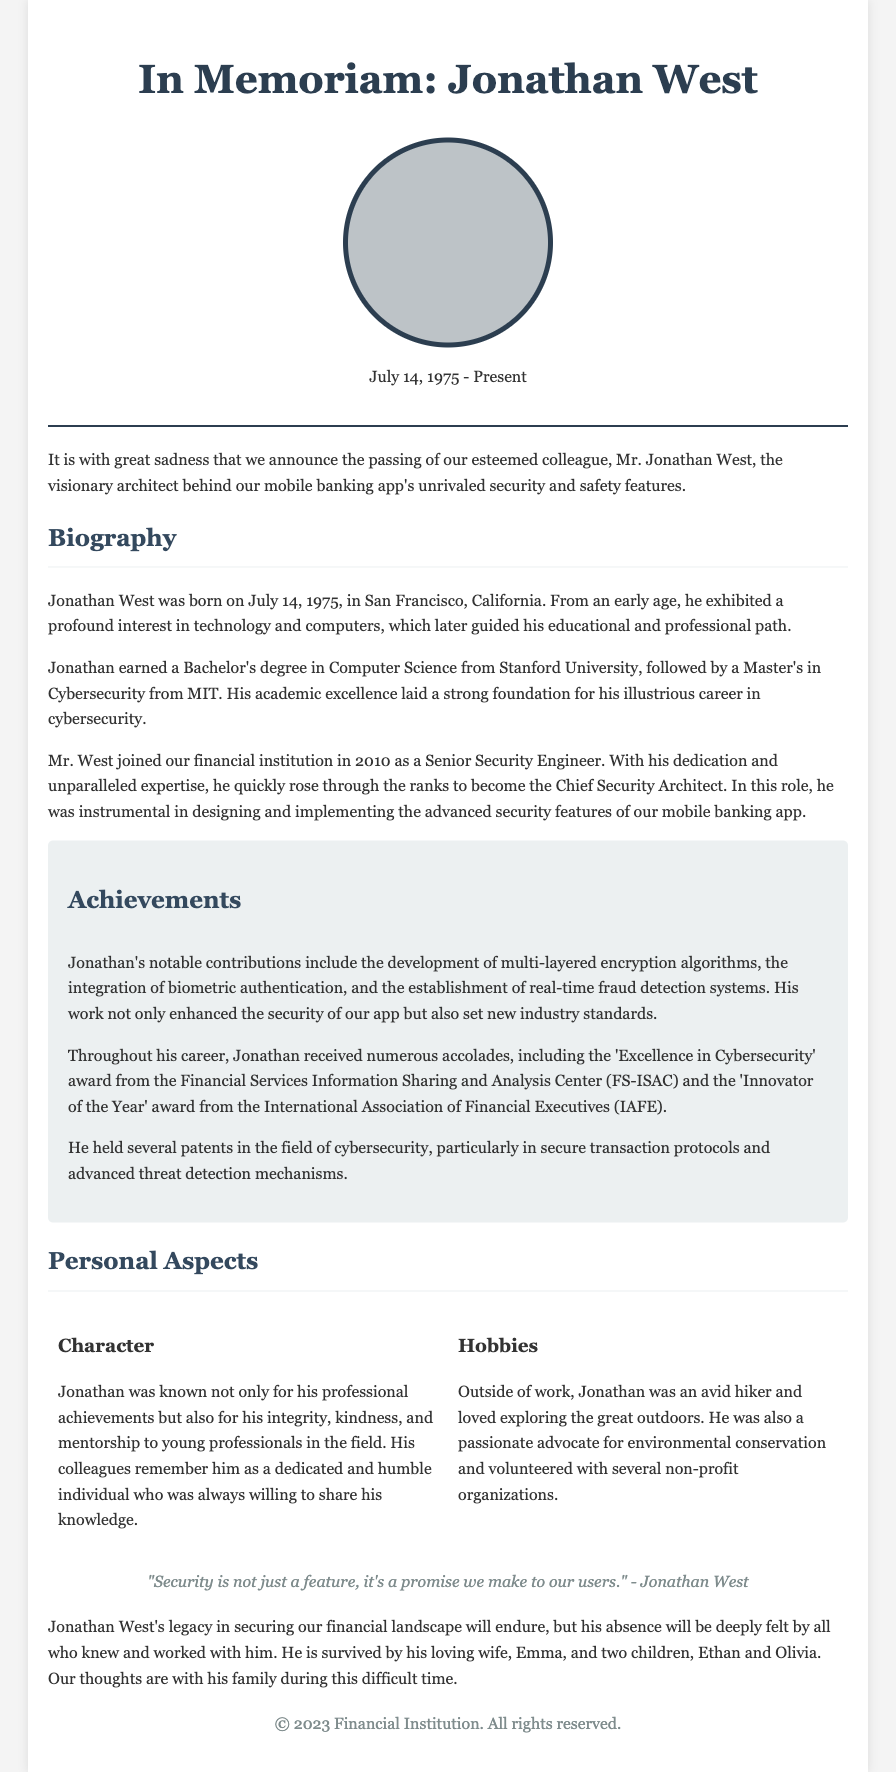What is the full name of the individual honored in this obituary? The full name of the individual is mentioned in the title "In Memoriam: Jonathan West."
Answer: Jonathan West When was Jonathan West born? The document states his birth date as July 14, 1975.
Answer: July 14, 1975 What position did Jonathan West hold at the financial institution? The document mentions that he became the Chief Security Architect.
Answer: Chief Security Architect Which university did Jonathan West attend for his undergraduate degree? The document indicates that he earned a Bachelor's degree from Stanford University.
Answer: Stanford University What is one of the key achievements mentioned regarding Jonathan West's contributions? The achievements include the development of multi-layered encryption algorithms.
Answer: Multi-layered encryption algorithms According to the document, what was Jonathan's quote about security? The quote about security is included in the document as a personal reflection.
Answer: "Security is not just a feature, it's a promise we make to our users." How many children did Jonathan West have? The document states he is survived by two children, which indicates the number.
Answer: Two What award did Jonathan West receive from the Financial Services Information Sharing and Analysis Center? The document specifies that he received the 'Excellence in Cybersecurity' award.
Answer: Excellence in Cybersecurity What was one of Jonathan West's hobbies mentioned in the obituary? The document references that he was an avid hiker.
Answer: Avid hiker 